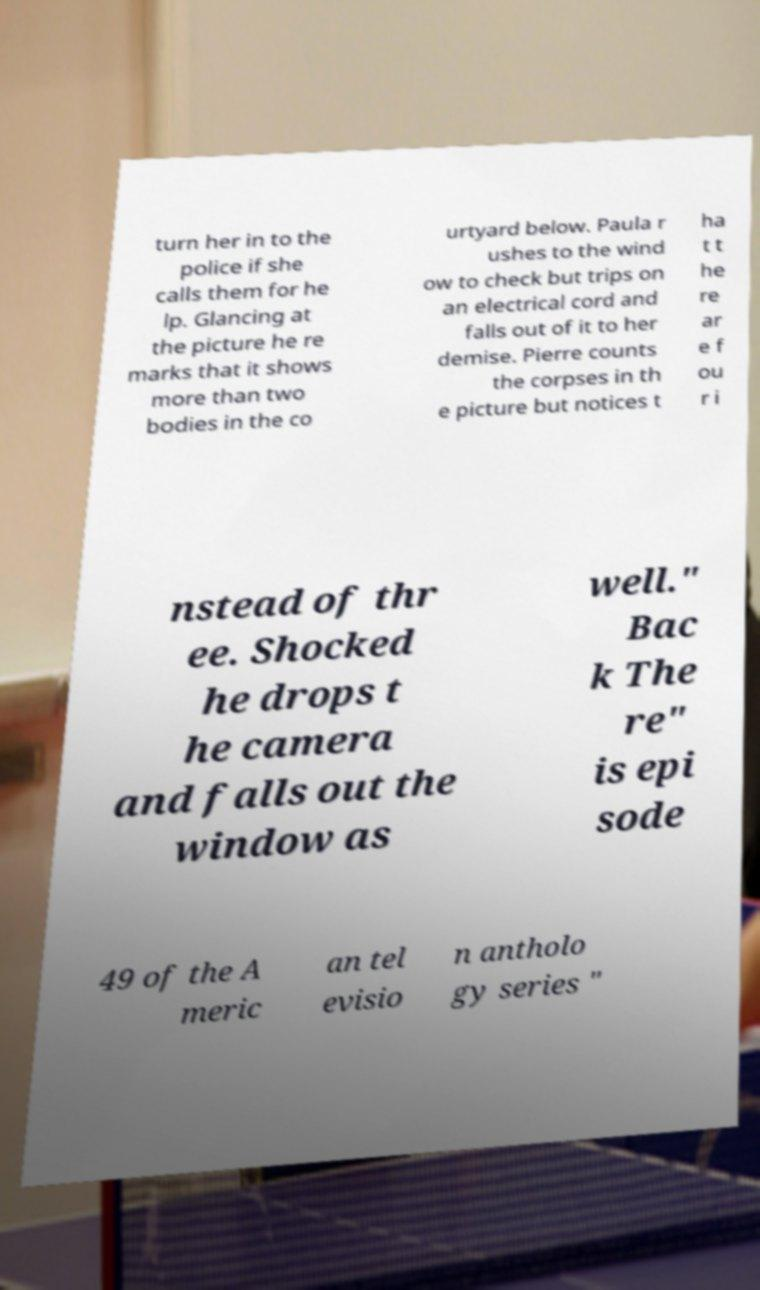What messages or text are displayed in this image? I need them in a readable, typed format. turn her in to the police if she calls them for he lp. Glancing at the picture he re marks that it shows more than two bodies in the co urtyard below. Paula r ushes to the wind ow to check but trips on an electrical cord and falls out of it to her demise. Pierre counts the corpses in th e picture but notices t ha t t he re ar e f ou r i nstead of thr ee. Shocked he drops t he camera and falls out the window as well." Bac k The re" is epi sode 49 of the A meric an tel evisio n antholo gy series " 